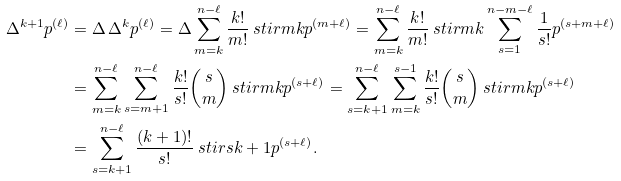Convert formula to latex. <formula><loc_0><loc_0><loc_500><loc_500>\Delta ^ { k + 1 } p ^ { ( \ell ) } & = \Delta \, \Delta ^ { k } p ^ { ( \ell ) } = \Delta \sum _ { m = k } ^ { n - \ell } \frac { k ! } { m ! } \ s t i r { m } { k } p ^ { ( m + \ell ) } = \sum _ { m = k } ^ { n - \ell } \frac { k ! } { m ! } \ s t i r { m } { k } \sum _ { s = 1 } ^ { n - m - \ell } \frac { 1 } { s ! } p ^ { ( s + m + \ell ) } \\ & = \sum _ { m = k } ^ { n - \ell } \sum _ { s = m + 1 } ^ { n - \ell } \frac { k ! } { s ! } { s \choose m } \ s t i r { m } { k } p ^ { ( s + \ell ) } = \sum _ { s = k + 1 } ^ { n - \ell } \sum _ { m = k } ^ { s - 1 } \frac { k ! } { s ! } { s \choose m } \ s t i r { m } { k } p ^ { ( s + \ell ) } \\ & = \sum _ { s = k + 1 } ^ { n - \ell } \frac { ( k + 1 ) ! } { s ! } \ s t i r { s } { k + 1 } p ^ { ( s + \ell ) } .</formula> 